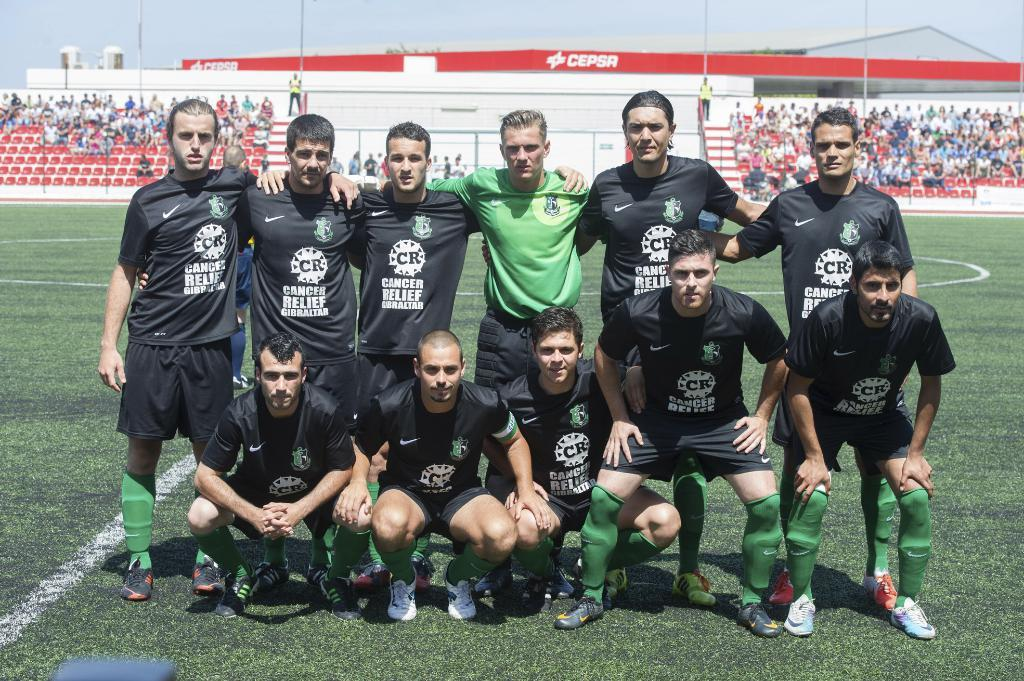<image>
Relay a brief, clear account of the picture shown. A sports team in Cancer Relief Gibraltar shirts poses together. 